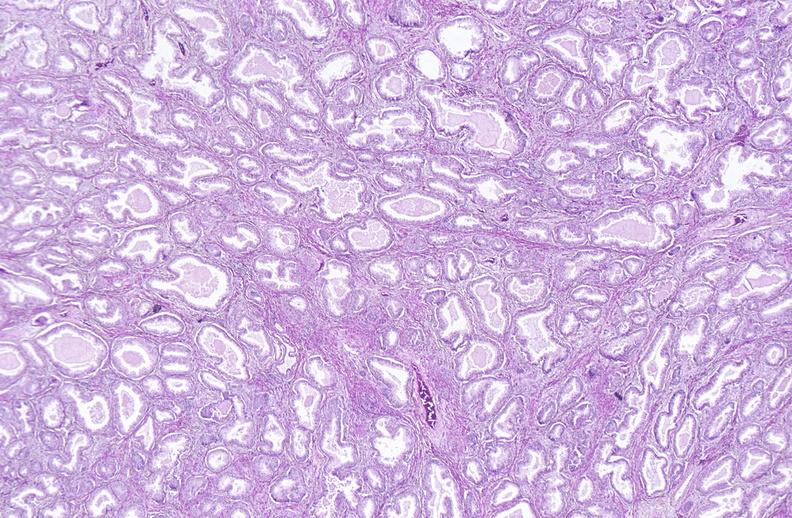does this image show prostate, benign prostatic hyperplasia?
Answer the question using a single word or phrase. Yes 